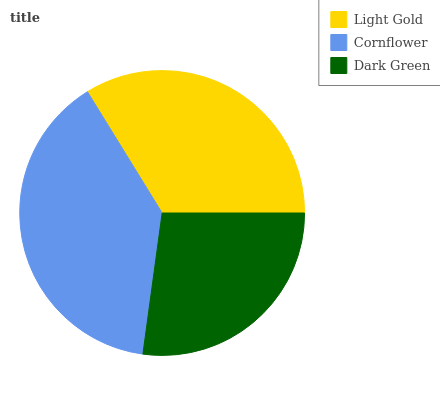Is Dark Green the minimum?
Answer yes or no. Yes. Is Cornflower the maximum?
Answer yes or no. Yes. Is Cornflower the minimum?
Answer yes or no. No. Is Dark Green the maximum?
Answer yes or no. No. Is Cornflower greater than Dark Green?
Answer yes or no. Yes. Is Dark Green less than Cornflower?
Answer yes or no. Yes. Is Dark Green greater than Cornflower?
Answer yes or no. No. Is Cornflower less than Dark Green?
Answer yes or no. No. Is Light Gold the high median?
Answer yes or no. Yes. Is Light Gold the low median?
Answer yes or no. Yes. Is Dark Green the high median?
Answer yes or no. No. Is Dark Green the low median?
Answer yes or no. No. 